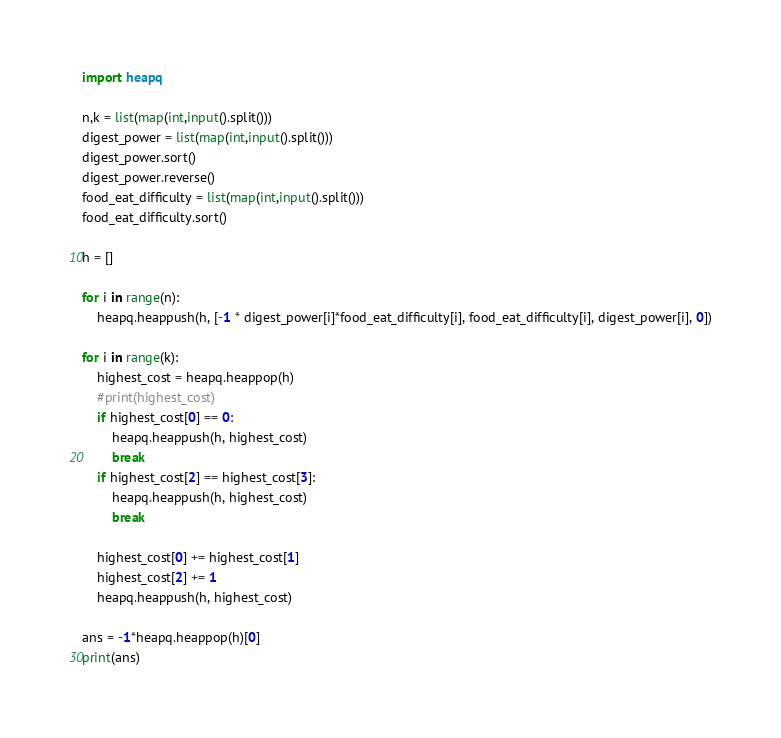<code> <loc_0><loc_0><loc_500><loc_500><_Python_>import heapq

n,k = list(map(int,input().split()))
digest_power = list(map(int,input().split()))
digest_power.sort()
digest_power.reverse()
food_eat_difficulty = list(map(int,input().split()))
food_eat_difficulty.sort()

h = []

for i in range(n):
    heapq.heappush(h, [-1 * digest_power[i]*food_eat_difficulty[i], food_eat_difficulty[i], digest_power[i], 0])

for i in range(k):
    highest_cost = heapq.heappop(h)
    #print(highest_cost)
    if highest_cost[0] == 0:
        heapq.heappush(h, highest_cost)
        break
    if highest_cost[2] == highest_cost[3]:
        heapq.heappush(h, highest_cost)
        break
    
    highest_cost[0] += highest_cost[1]
    highest_cost[2] += 1
    heapq.heappush(h, highest_cost)
          
ans = -1*heapq.heappop(h)[0]
print(ans)</code> 